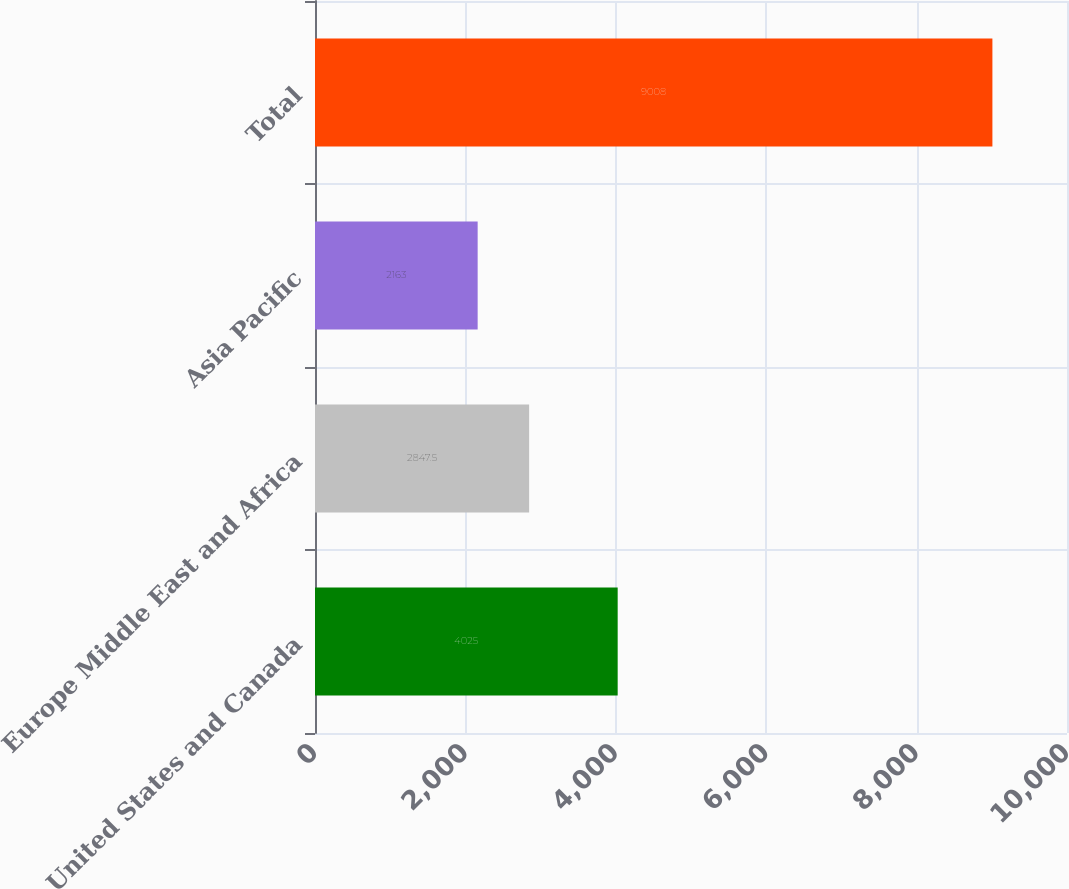Convert chart to OTSL. <chart><loc_0><loc_0><loc_500><loc_500><bar_chart><fcel>United States and Canada<fcel>Europe Middle East and Africa<fcel>Asia Pacific<fcel>Total<nl><fcel>4025<fcel>2847.5<fcel>2163<fcel>9008<nl></chart> 